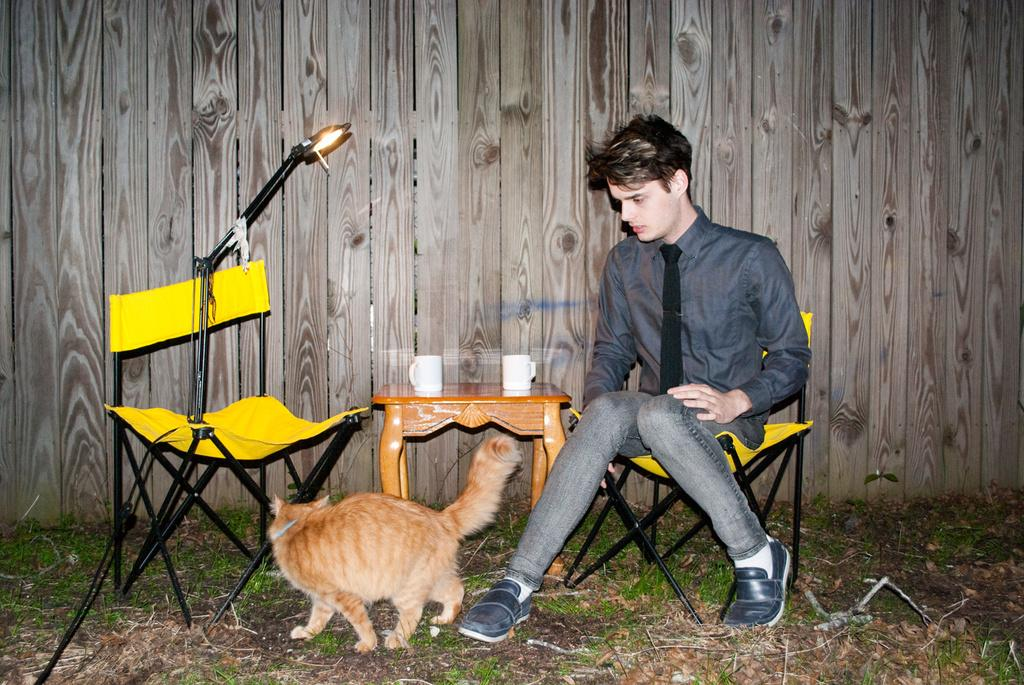How many chairs are in the image? There are 2 chairs in the image. What is the boy doing in the image? A boy is sitting on one of the chairs. What is on the table in the image? There are 2 mugs on the table. Can you describe the cat's location in the image? The cat is visible in the image, and it is on the grass. What type of cherry is the boy eating while talking to the cat during the operation? There is no cherry, operation, or talking to the cat in the image. The boy is simply sitting on a chair, and the cat is on the grass. 